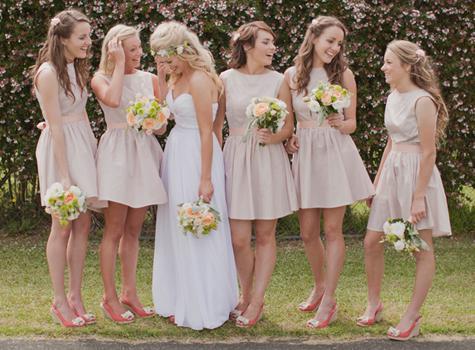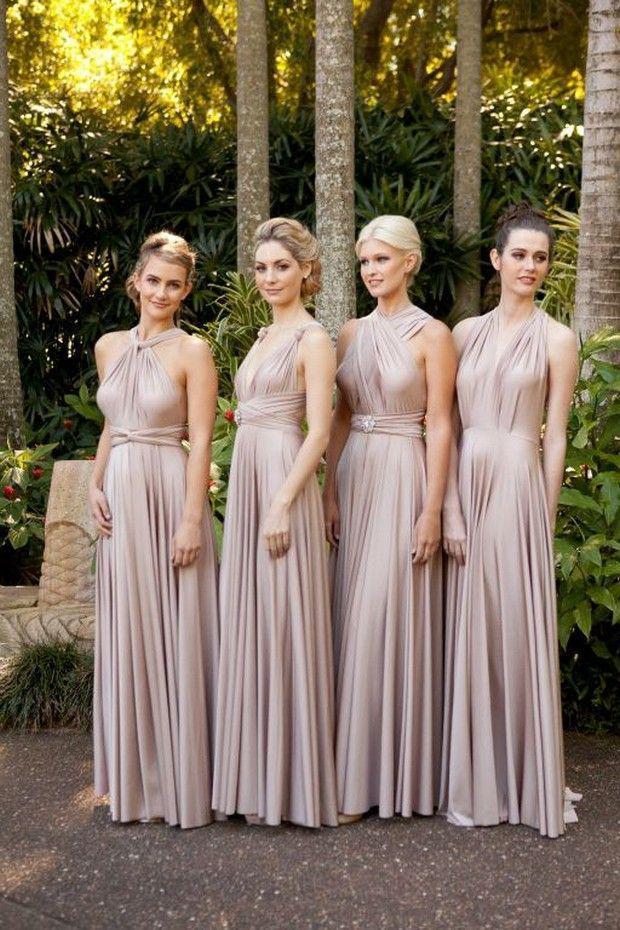The first image is the image on the left, the second image is the image on the right. For the images shown, is this caption "There are three women in the left image" true? Answer yes or no. No. The first image is the image on the left, the second image is the image on the right. For the images shown, is this caption "In one image, exactly four women are shown standing in a row." true? Answer yes or no. Yes. 